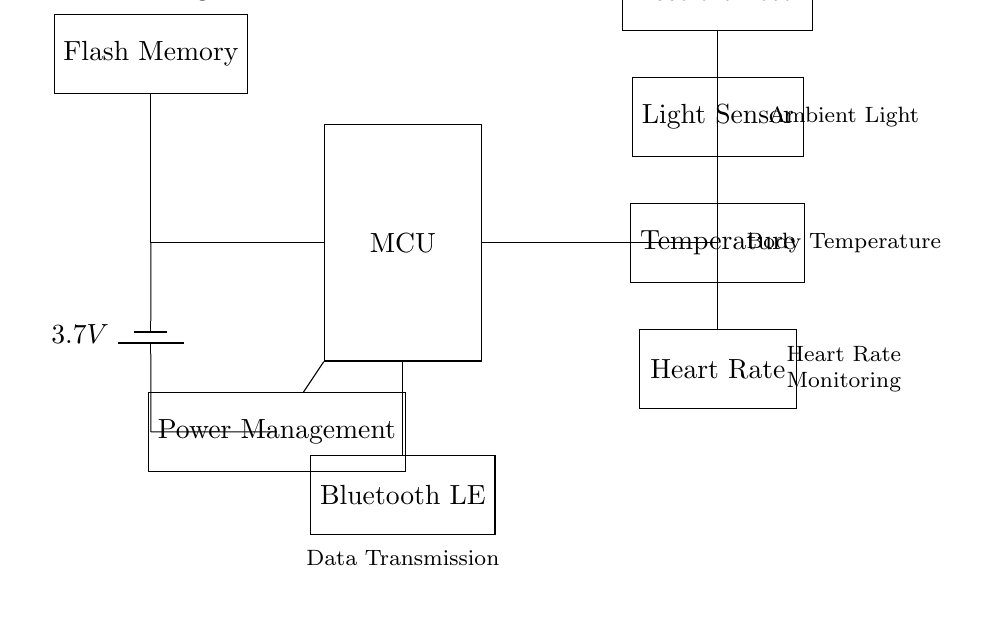What is the voltage of the battery? The voltage is indicated as 3.7 volts on the battery symbol in the circuit diagram.
Answer: 3.7 volts What components are used for motion detection? The accelerometer is identified in the circuit diagram as the component responsible for motion detection.
Answer: Accelerometer How many sensors are included in the circuit? The circuit diagram includes four sensors (Accelerometer, Light Sensor, Temperature, and Heart Rate), which can be counted in the diagram.
Answer: Four Which component is responsible for data transmission? The Bluetooth LE module is identified in the circuit diagram as the component used for data transmission, specifically noted at the bottom of the circuit.
Answer: Bluetooth LE How does the microcontroller connect to the power management unit? The microcontroller is connected directly to the power management unit, showing a line from the MCU to the PMU, indicating a direct electrical connection.
Answer: Direct connection What is the purpose of the flash memory in the circuit? The flash memory is identified in the circuit as a component for data storage, which is crucial for retaining the information gathered by the sensors for later retrieval.
Answer: Data storage Explain the relationship between the sensors and the microcontroller. The microcontroller connects to all four sensors (accelerometer, light sensor, temperature, and heart rate) via branches in the circuit, indicating that it processes data from each of them, making it the central processing unit.
Answer: Data processing hub 